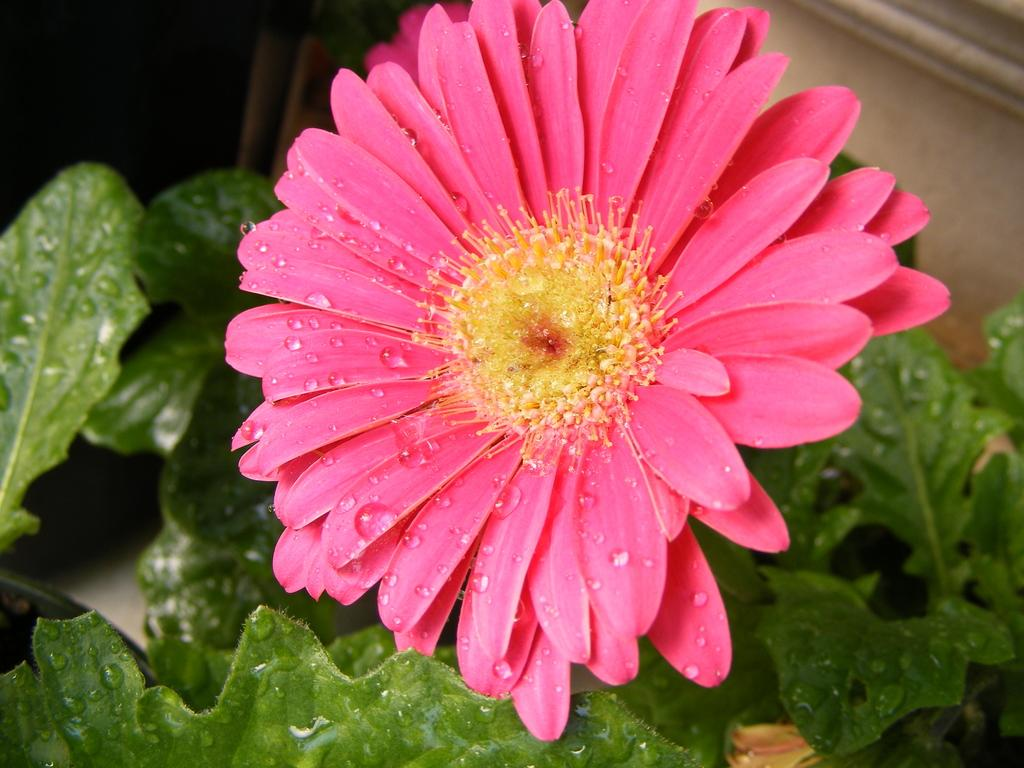What type of flower is in the image? There is a pink color flower in the image. What can be seen in the background of the image? There are leaves and a wall in the background of the image. How many people are in the crowd around the flower in the image? There is no crowd present in the image; it only features the pink color flower and the background elements. 